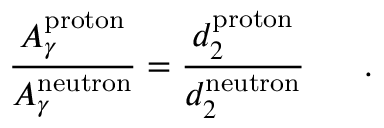Convert formula to latex. <formula><loc_0><loc_0><loc_500><loc_500>{ \frac { A _ { \gamma } ^ { p r o t o n } } { A _ { \gamma } ^ { n e u t r o n } } } = { \frac { d _ { 2 } ^ { p r o t o n } } { d _ { 2 } ^ { n e u t r o n } } } .</formula> 